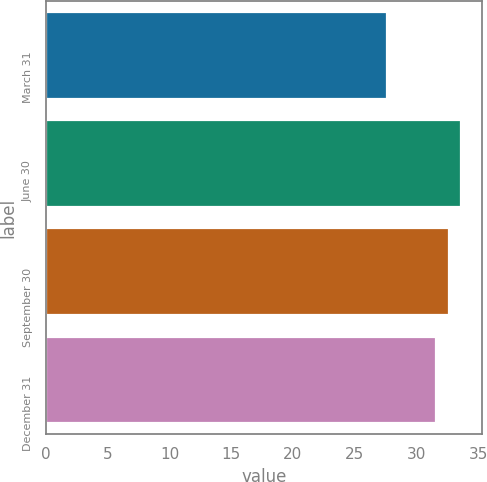Convert chart to OTSL. <chart><loc_0><loc_0><loc_500><loc_500><bar_chart><fcel>March 31<fcel>June 30<fcel>September 30<fcel>December 31<nl><fcel>27.64<fcel>33.6<fcel>32.65<fcel>31.56<nl></chart> 